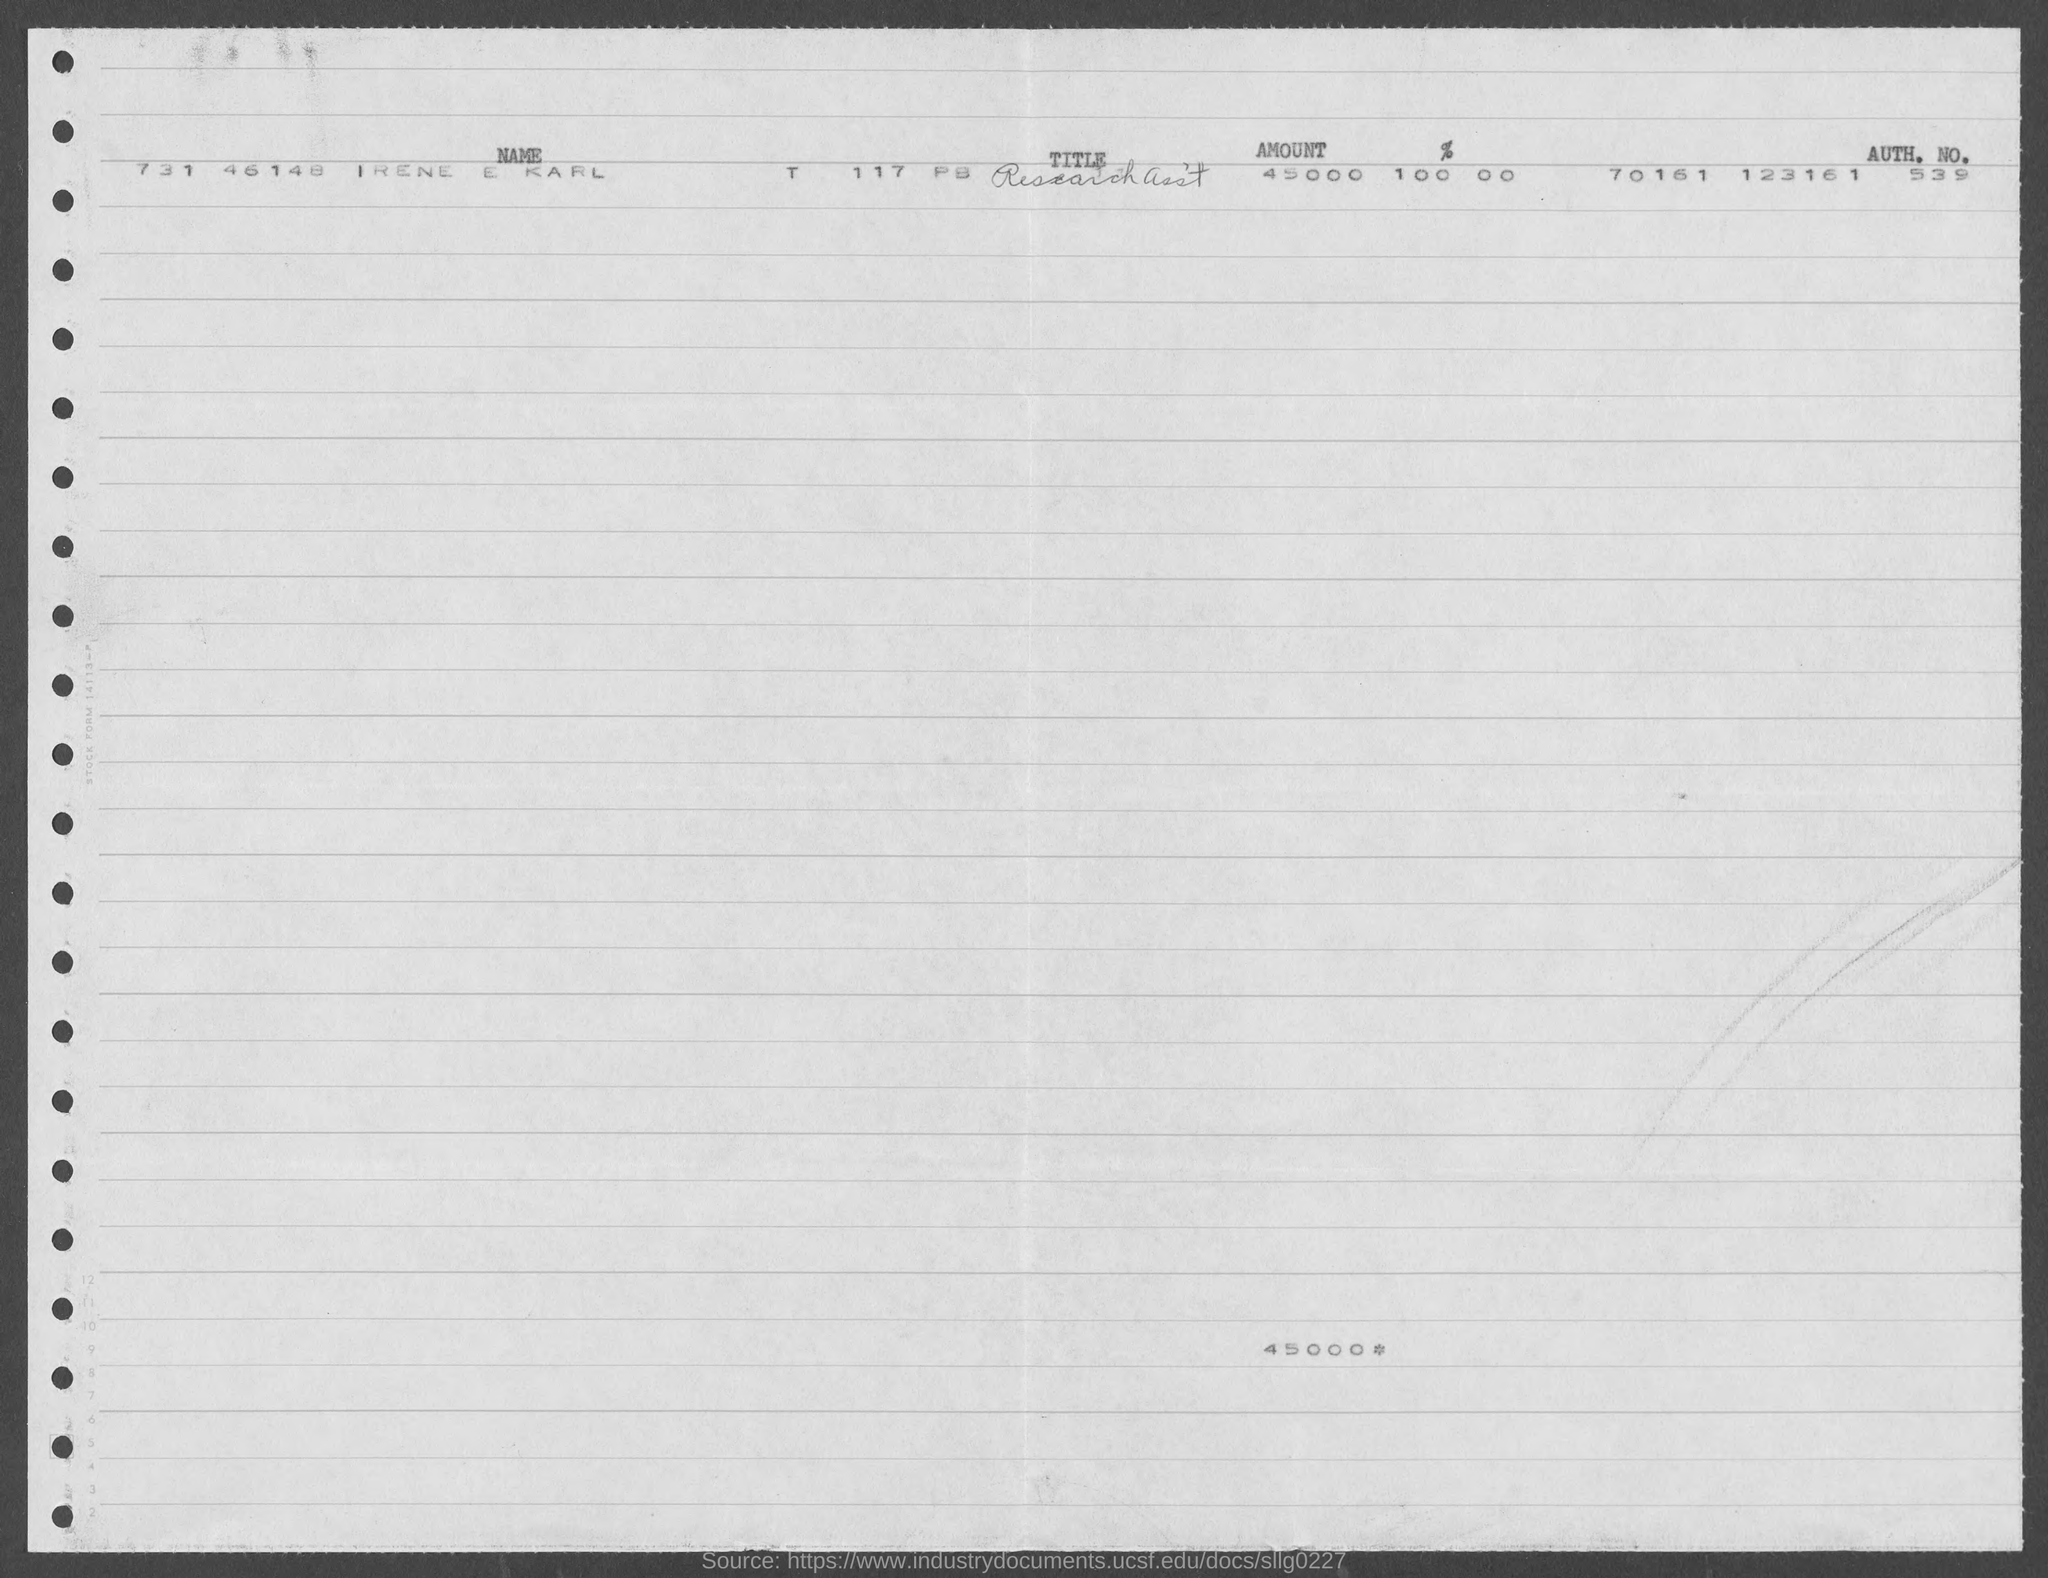Identify some key points in this picture. The name of the person is Irene E Karl. The amount is 45,000. The title of this research assistant's work is not specified. 